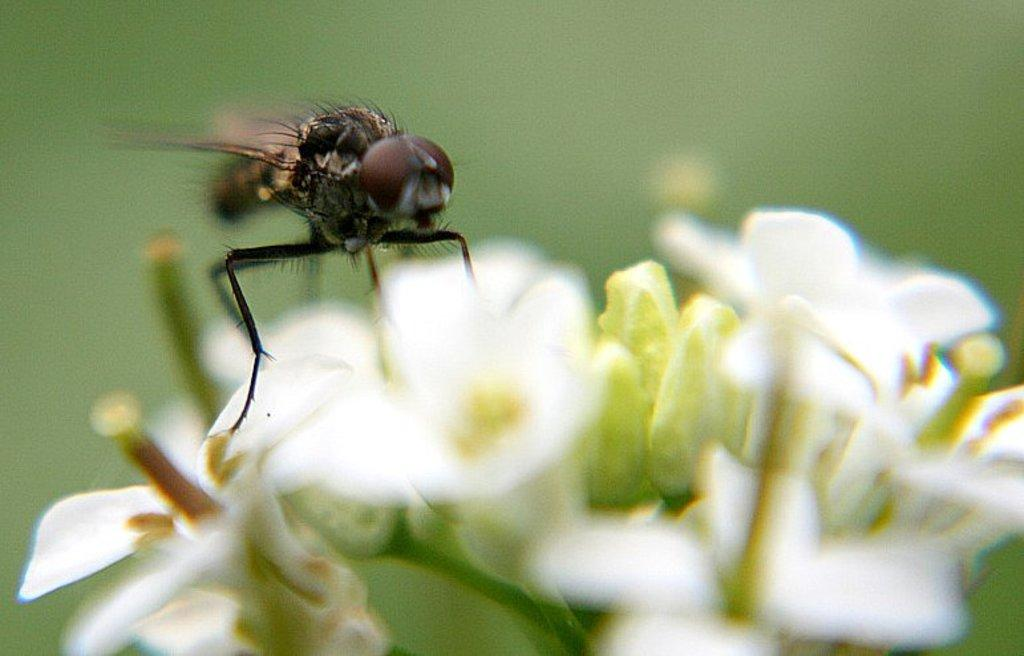What is the main subject of the image? There is an insect on a flower in the image. Can you describe the flower in the image? The flower is white. What can be observed about the background of the image? The background of the image is blurred. What type of book is the insect reading in the image? There is no book present in the image; it features an insect on a white flower with a blurred background. 